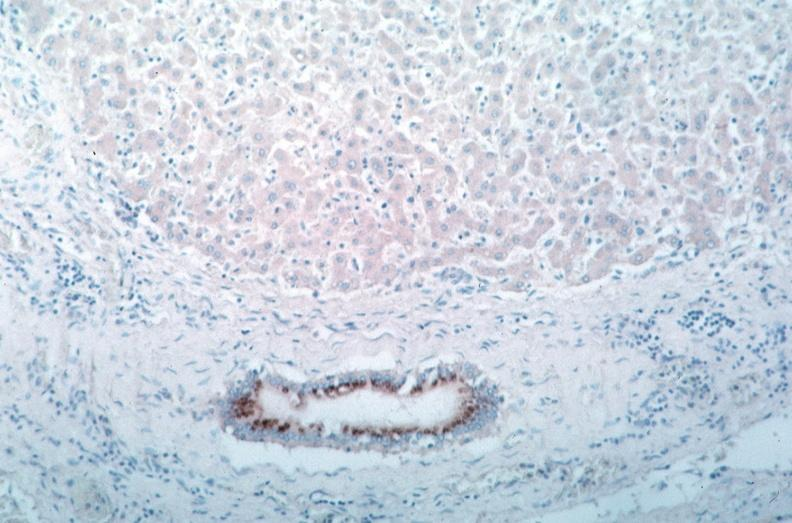s vasculature present?
Answer the question using a single word or phrase. Yes 